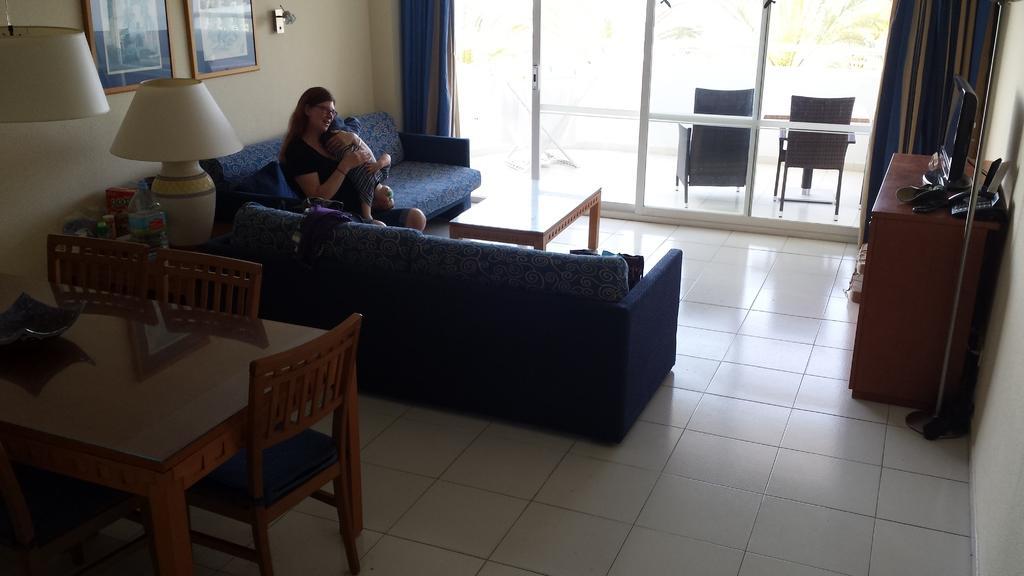Could you give a brief overview of what you see in this image? A picture is taken inside a closed room where at the left corner of the picture one blue sofa is present and one woman is sitting on it and carrying a baby and there is one table with chairs and bed lamps and behind her there is a wall with photos on it and beside her there is big glass window with curtains on it and outside that there are two chairs and trees are present and at the right corner of the picture there is one wooden table with shelves and one system and telephone are present on it and in the middle there is one table. 